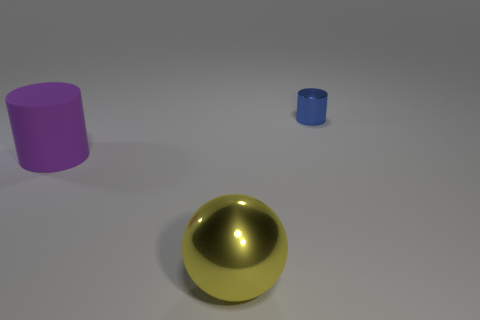There is a cylinder that is on the left side of the blue cylinder; is it the same size as the metallic thing that is in front of the tiny metal thing?
Provide a short and direct response. Yes. What number of large things are spheres or purple objects?
Provide a short and direct response. 2. What number of things are both on the right side of the purple cylinder and behind the yellow metal thing?
Your response must be concise. 1. Does the small blue cylinder have the same material as the cylinder to the left of the small metallic cylinder?
Make the answer very short. No. What number of blue things are spheres or tiny metallic cylinders?
Your response must be concise. 1. Is there a sphere of the same size as the purple cylinder?
Offer a very short reply. Yes. The cylinder to the left of the shiny thing that is in front of the metallic object that is to the right of the large shiny thing is made of what material?
Keep it short and to the point. Rubber. Are there the same number of blue cylinders that are behind the tiny blue metallic cylinder and rubber objects?
Your answer should be very brief. No. Does the cylinder left of the big sphere have the same material as the cylinder that is on the right side of the ball?
Provide a succinct answer. No. How many things are large blue metallic blocks or objects that are left of the large metallic ball?
Your answer should be compact. 1. 